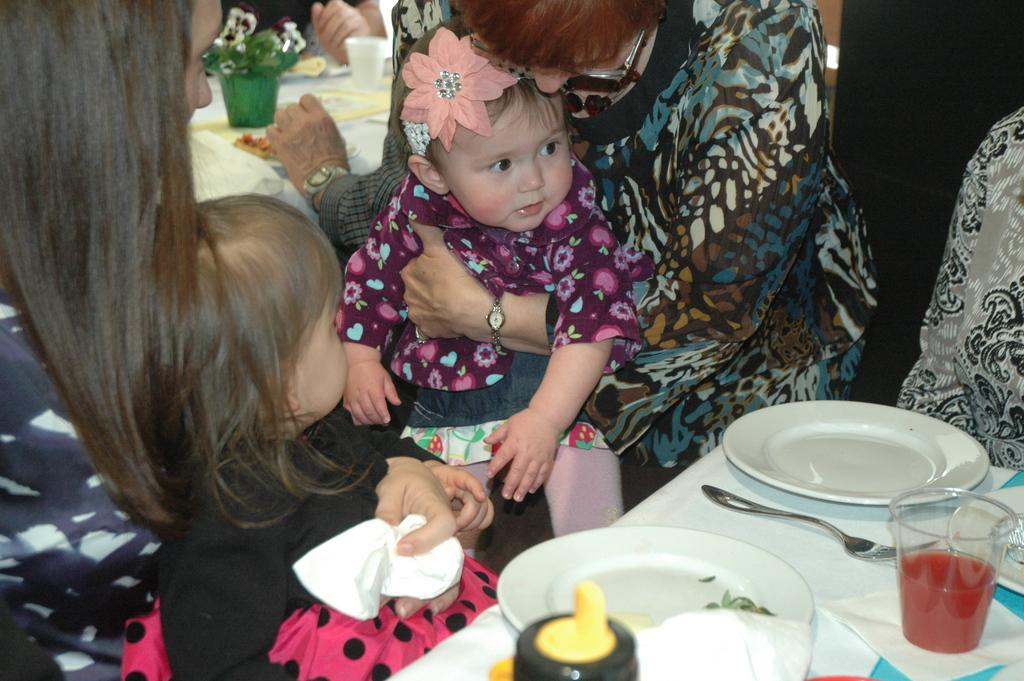How many people are in the image? There are persons in the image, but the exact number cannot be determined from the provided facts. What is present on the table in the image? There is a table in the image, and on it, there are plates, a bottle, and a glass. What might be used for drinking in the image? The glass on the table might be used for drinking. What type of volleyball game is being played in the image? There is no volleyball game or any reference to sports in the image. 